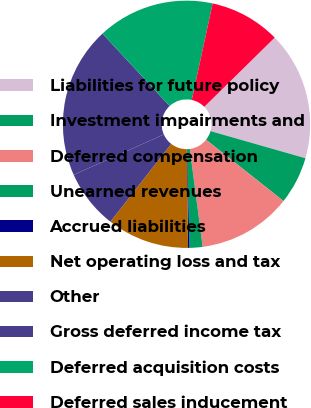<chart> <loc_0><loc_0><loc_500><loc_500><pie_chart><fcel>Liabilities for future policy<fcel>Investment impairments and<fcel>Deferred compensation<fcel>Unearned revenues<fcel>Accrued liabilities<fcel>Net operating loss and tax<fcel>Other<fcel>Gross deferred income tax<fcel>Deferred acquisition costs<fcel>Deferred sales inducement<nl><fcel>16.79%<fcel>6.23%<fcel>12.26%<fcel>1.7%<fcel>0.19%<fcel>10.75%<fcel>7.74%<fcel>19.81%<fcel>15.28%<fcel>9.25%<nl></chart> 